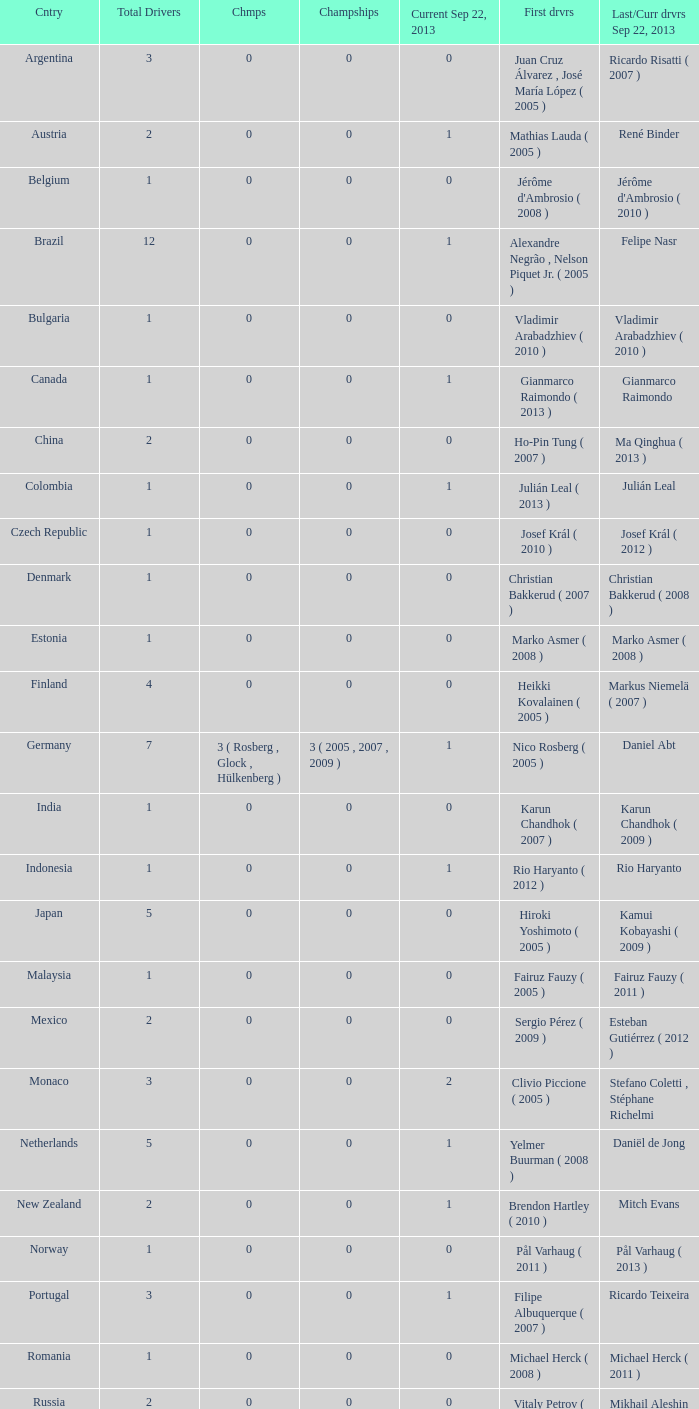How many champions were there when the last driver was Gianmarco Raimondo? 0.0. 